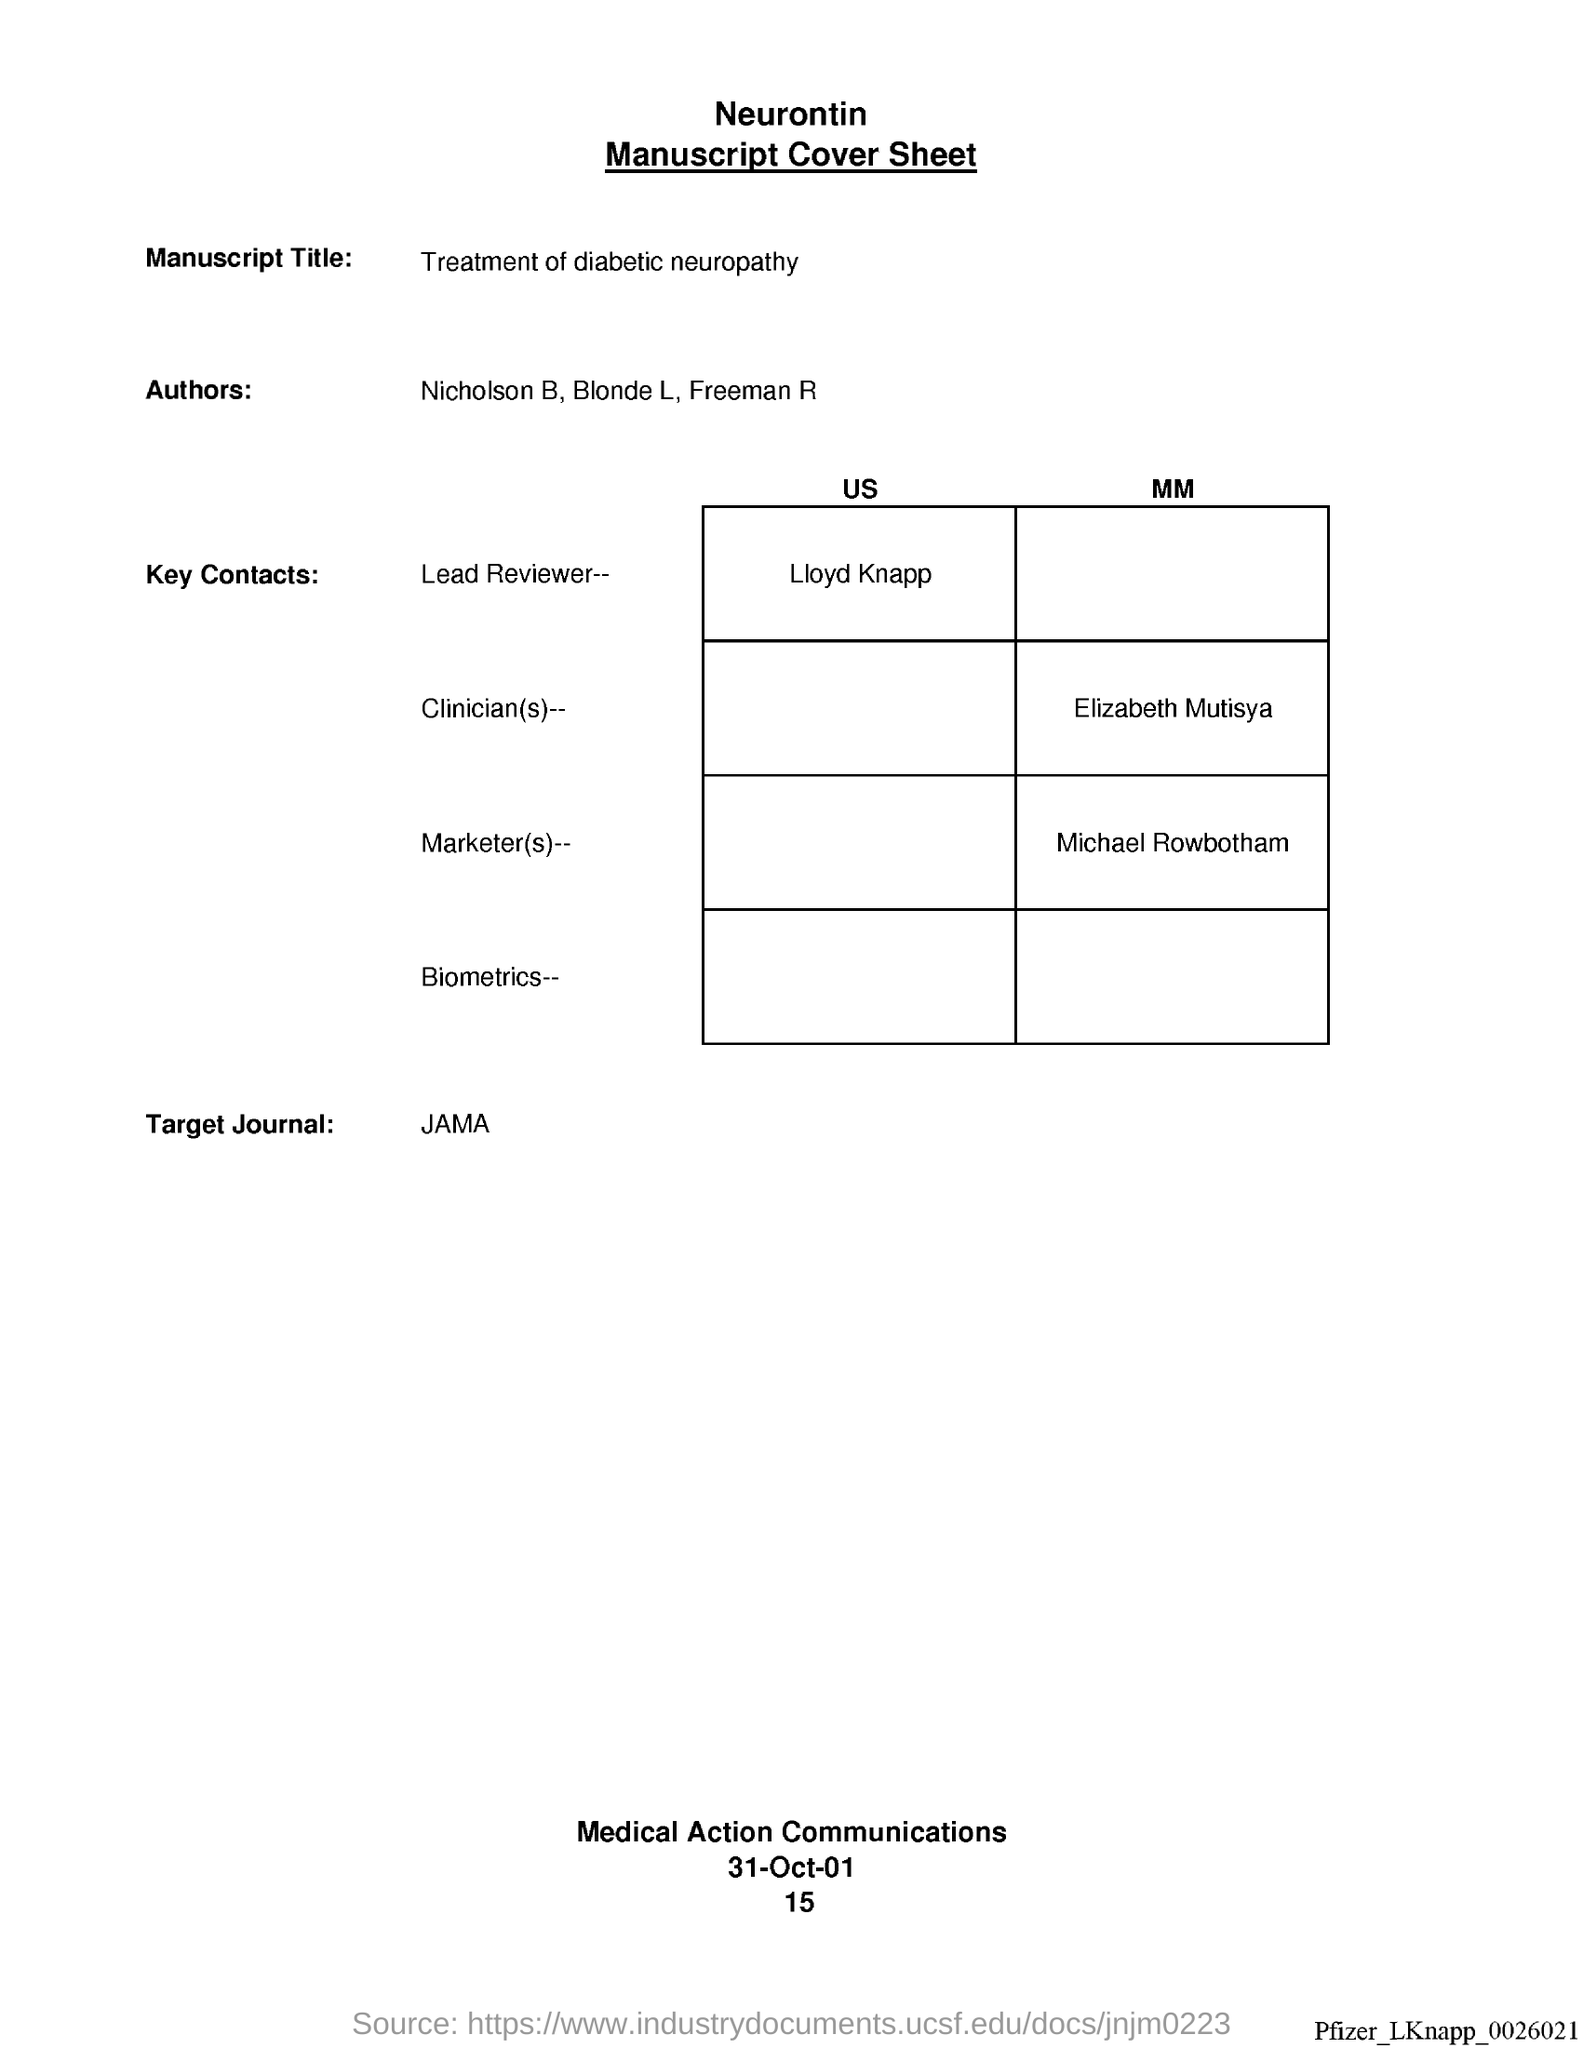List a handful of essential elements in this visual. The lead reviewer is named Lloyd Knapp from the United States. This manuscript explores the treatment of diabetic neuropathy. The Clinician is MM, and their name is Elizabeth Mutisya. The market(s) is referred to as MM, and it is Michael Rowbotham. The target journal is JAMA. 